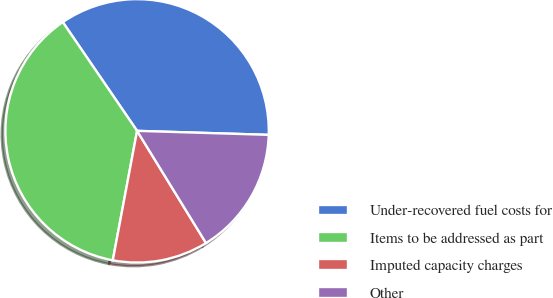<chart> <loc_0><loc_0><loc_500><loc_500><pie_chart><fcel>Under-recovered fuel costs for<fcel>Items to be addressed as part<fcel>Imputed capacity charges<fcel>Other<nl><fcel>35.03%<fcel>37.51%<fcel>11.72%<fcel>15.75%<nl></chart> 